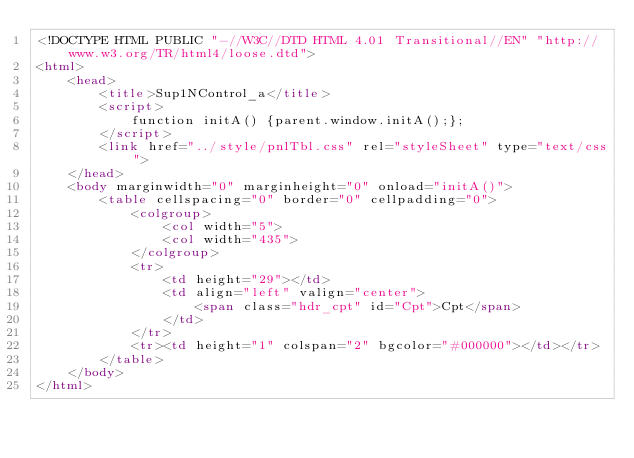Convert code to text. <code><loc_0><loc_0><loc_500><loc_500><_HTML_><!DOCTYPE HTML PUBLIC "-//W3C//DTD HTML 4.01 Transitional//EN" "http://www.w3.org/TR/html4/loose.dtd">
<html>
	<head>
		<title>Sup1NControl_a</title>
		<script>
			function initA() {parent.window.initA();};
		</script>
		<link href="../style/pnlTbl.css" rel="styleSheet" type="text/css">
	</head>
	<body marginwidth="0" marginheight="0" onload="initA()">
		<table cellspacing="0" border="0" cellpadding="0">
			<colgroup>
				<col width="5">
				<col width="435">
			</colgroup>
			<tr>
				<td height="29"></td>
				<td align="left" valign="center">
					<span class="hdr_cpt" id="Cpt">Cpt</span>
				</td>
			</tr>
			<tr><td height="1" colspan="2" bgcolor="#000000"></td></tr>
		</table>
	</body>
</html>
</code> 